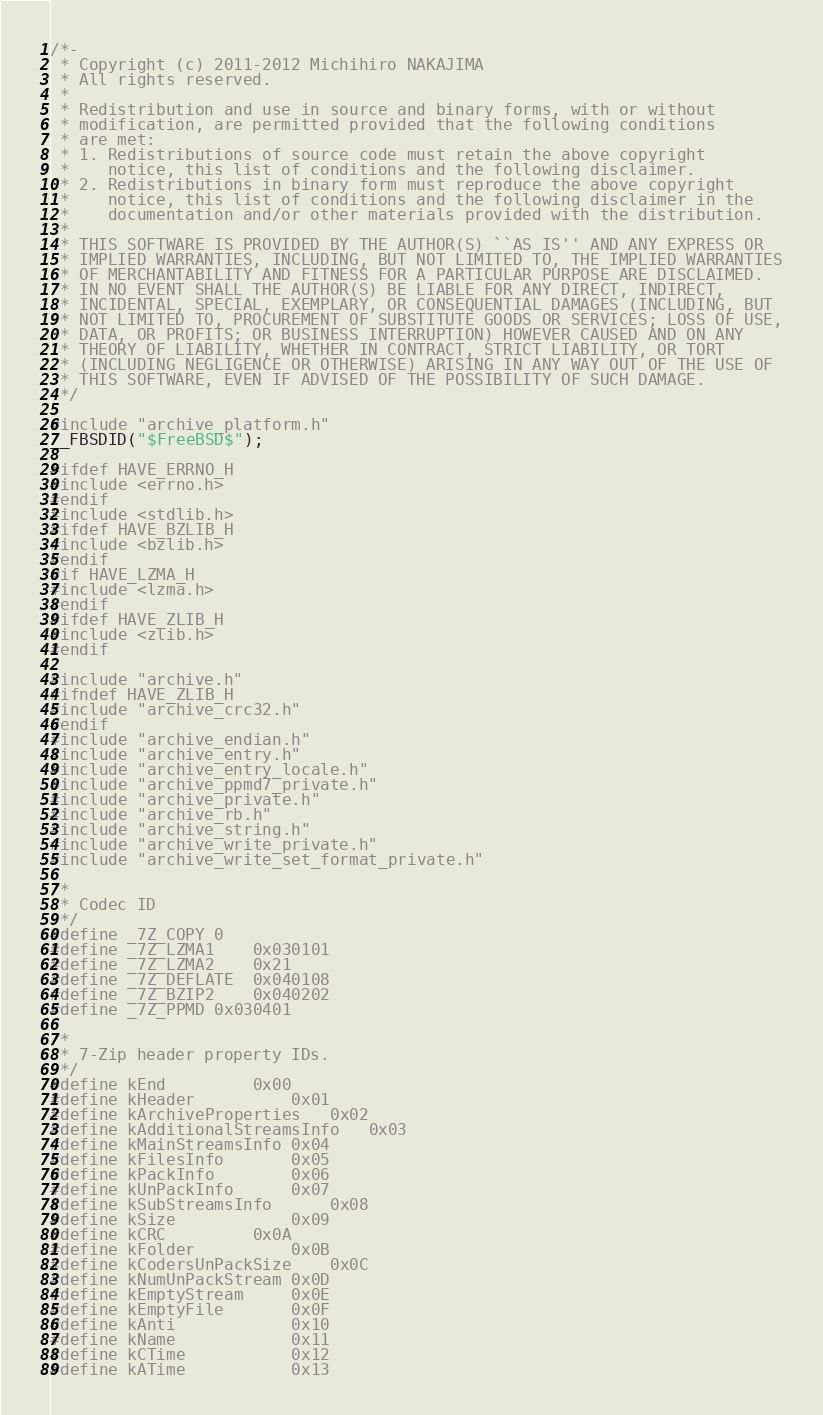<code> <loc_0><loc_0><loc_500><loc_500><_C_>/*-
 * Copyright (c) 2011-2012 Michihiro NAKAJIMA
 * All rights reserved.
 *
 * Redistribution and use in source and binary forms, with or without
 * modification, are permitted provided that the following conditions
 * are met:
 * 1. Redistributions of source code must retain the above copyright
 *    notice, this list of conditions and the following disclaimer.
 * 2. Redistributions in binary form must reproduce the above copyright
 *    notice, this list of conditions and the following disclaimer in the
 *    documentation and/or other materials provided with the distribution.
 *
 * THIS SOFTWARE IS PROVIDED BY THE AUTHOR(S) ``AS IS'' AND ANY EXPRESS OR
 * IMPLIED WARRANTIES, INCLUDING, BUT NOT LIMITED TO, THE IMPLIED WARRANTIES
 * OF MERCHANTABILITY AND FITNESS FOR A PARTICULAR PURPOSE ARE DISCLAIMED.
 * IN NO EVENT SHALL THE AUTHOR(S) BE LIABLE FOR ANY DIRECT, INDIRECT,
 * INCIDENTAL, SPECIAL, EXEMPLARY, OR CONSEQUENTIAL DAMAGES (INCLUDING, BUT
 * NOT LIMITED TO, PROCUREMENT OF SUBSTITUTE GOODS OR SERVICES; LOSS OF USE,
 * DATA, OR PROFITS; OR BUSINESS INTERRUPTION) HOWEVER CAUSED AND ON ANY
 * THEORY OF LIABILITY, WHETHER IN CONTRACT, STRICT LIABILITY, OR TORT
 * (INCLUDING NEGLIGENCE OR OTHERWISE) ARISING IN ANY WAY OUT OF THE USE OF
 * THIS SOFTWARE, EVEN IF ADVISED OF THE POSSIBILITY OF SUCH DAMAGE.
 */

#include "archive_platform.h"
__FBSDID("$FreeBSD$");

#ifdef HAVE_ERRNO_H
#include <errno.h>
#endif
#include <stdlib.h>
#ifdef HAVE_BZLIB_H
#include <bzlib.h>
#endif
#if HAVE_LZMA_H
#include <lzma.h>
#endif
#ifdef HAVE_ZLIB_H
#include <zlib.h>
#endif

#include "archive.h"
#ifndef HAVE_ZLIB_H
#include "archive_crc32.h"
#endif
#include "archive_endian.h"
#include "archive_entry.h"
#include "archive_entry_locale.h"
#include "archive_ppmd7_private.h"
#include "archive_private.h"
#include "archive_rb.h"
#include "archive_string.h"
#include "archive_write_private.h"
#include "archive_write_set_format_private.h"

/*
 * Codec ID
 */
#define _7Z_COPY	0
#define _7Z_LZMA1	0x030101
#define _7Z_LZMA2	0x21
#define _7Z_DEFLATE	0x040108
#define _7Z_BZIP2	0x040202
#define _7Z_PPMD	0x030401

/*
 * 7-Zip header property IDs.
 */
#define kEnd			0x00
#define kHeader			0x01
#define kArchiveProperties	0x02
#define kAdditionalStreamsInfo	0x03
#define kMainStreamsInfo	0x04
#define kFilesInfo		0x05
#define kPackInfo		0x06
#define kUnPackInfo		0x07
#define kSubStreamsInfo		0x08
#define kSize			0x09
#define kCRC			0x0A
#define kFolder			0x0B
#define kCodersUnPackSize	0x0C
#define kNumUnPackStream	0x0D
#define kEmptyStream		0x0E
#define kEmptyFile		0x0F
#define kAnti			0x10
#define kName			0x11
#define kCTime			0x12
#define kATime			0x13</code> 